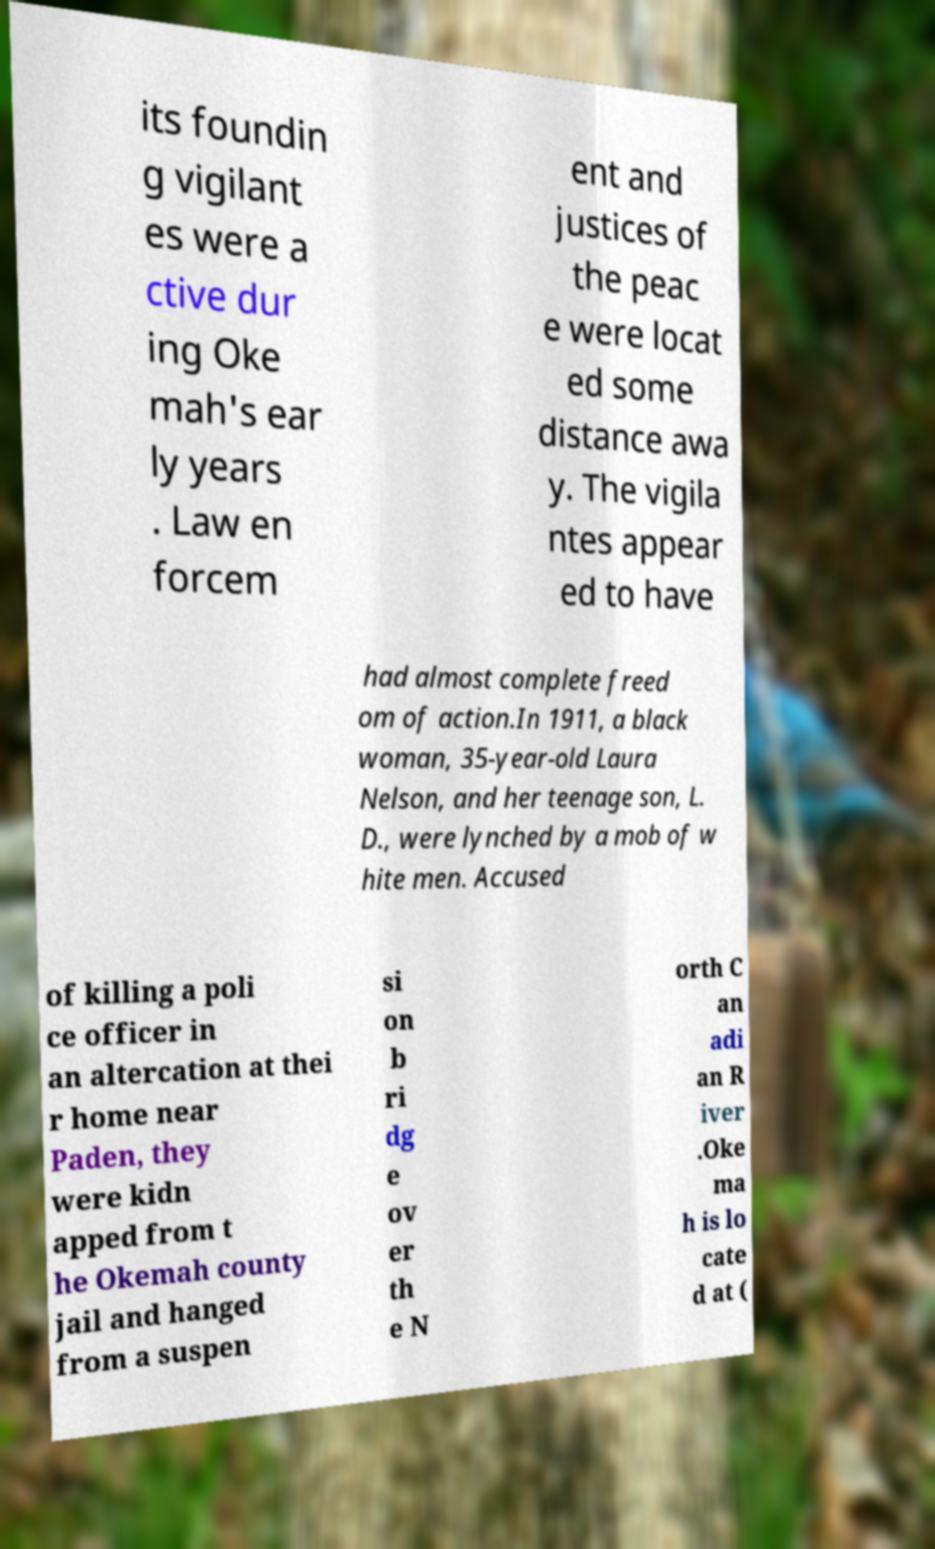Can you read and provide the text displayed in the image?This photo seems to have some interesting text. Can you extract and type it out for me? its foundin g vigilant es were a ctive dur ing Oke mah's ear ly years . Law en forcem ent and justices of the peac e were locat ed some distance awa y. The vigila ntes appear ed to have had almost complete freed om of action.In 1911, a black woman, 35-year-old Laura Nelson, and her teenage son, L. D., were lynched by a mob of w hite men. Accused of killing a poli ce officer in an altercation at thei r home near Paden, they were kidn apped from t he Okemah county jail and hanged from a suspen si on b ri dg e ov er th e N orth C an adi an R iver .Oke ma h is lo cate d at ( 